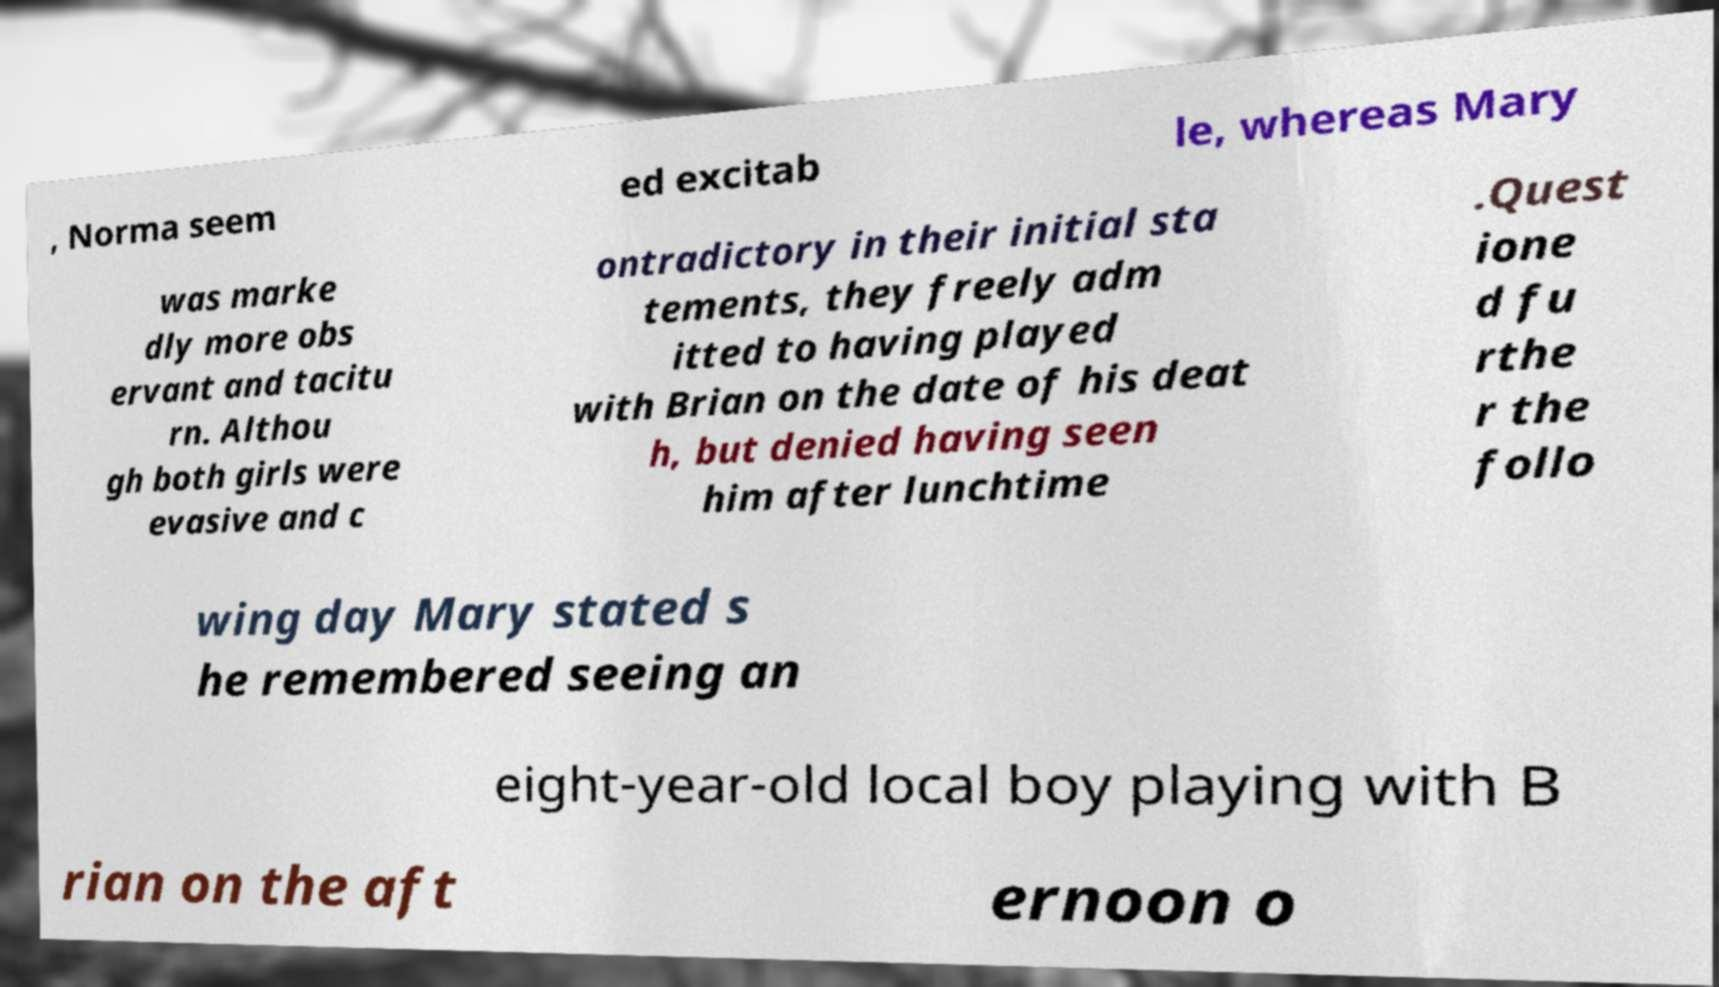I need the written content from this picture converted into text. Can you do that? , Norma seem ed excitab le, whereas Mary was marke dly more obs ervant and tacitu rn. Althou gh both girls were evasive and c ontradictory in their initial sta tements, they freely adm itted to having played with Brian on the date of his deat h, but denied having seen him after lunchtime .Quest ione d fu rthe r the follo wing day Mary stated s he remembered seeing an eight-year-old local boy playing with B rian on the aft ernoon o 